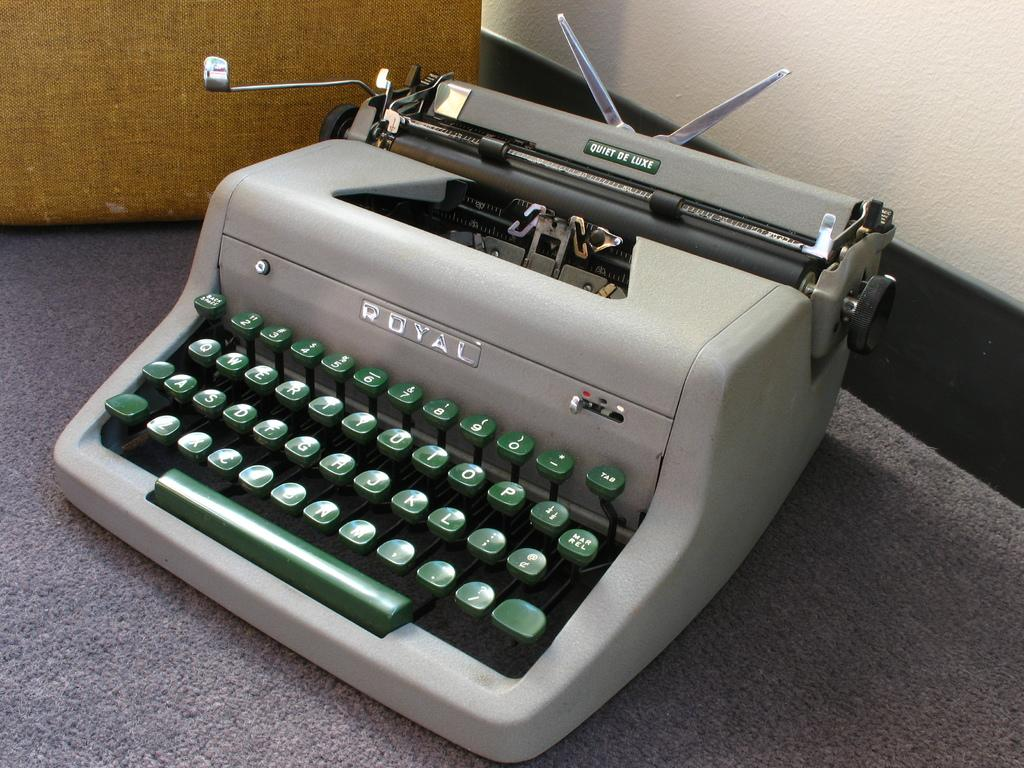<image>
Share a concise interpretation of the image provided. An old gray Royal typewriter with green keys. 